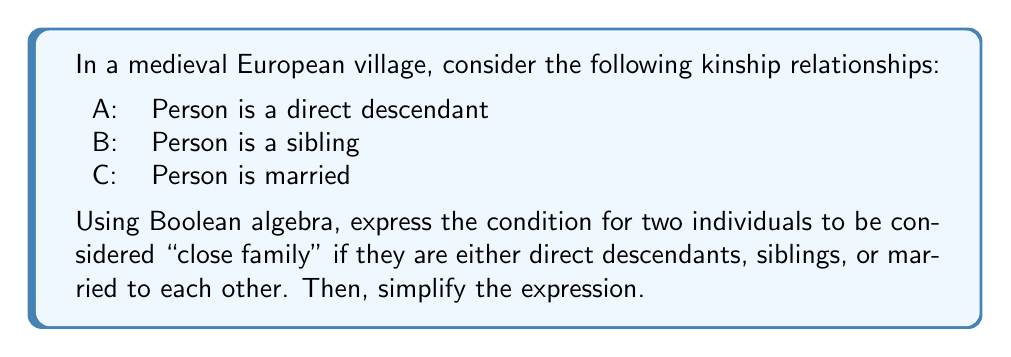Provide a solution to this math problem. Let's approach this step-by-step:

1. We need to express "close family" as a Boolean function of A, B, and C. Since individuals are considered close family if they are either direct descendants, siblings, or married, we can represent this using the OR operation:

   $$ F = A + B + C $$

   Where $F$ represents the "close family" relationship, and $+$ is the Boolean OR operator.

2. This expression is already in its simplest form in Boolean algebra. In set theory, this would be equivalent to the union of sets A, B, and C.

3. We can verify this using a truth table:

   | A | B | C | F |
   |---|---|---|---|
   | 0 | 0 | 0 | 0 |
   | 0 | 0 | 1 | 1 |
   | 0 | 1 | 0 | 1 |
   | 0 | 1 | 1 | 1 |
   | 1 | 0 | 0 | 1 |
   | 1 | 0 | 1 | 1 |
   | 1 | 1 | 0 | 1 |
   | 1 | 1 | 1 | 1 |

4. The truth table confirms that F is 1 (true) whenever at least one of A, B, or C is 1 (true).

5. In the context of medieval European kinship systems, this Boolean expression represents a simplified model of close family relationships, where any of these three conditions (direct descent, sibling relationship, or marriage) would classify individuals as close family.
Answer: $$ F = A + B + C $$ 